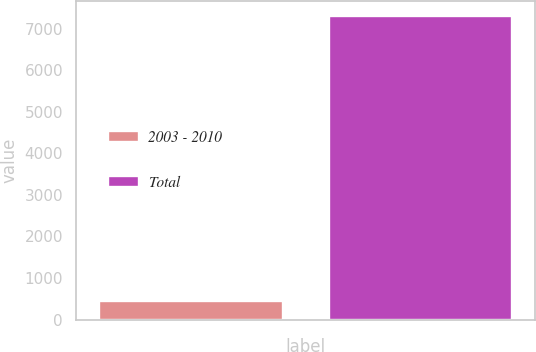<chart> <loc_0><loc_0><loc_500><loc_500><bar_chart><fcel>2003 - 2010<fcel>Total<nl><fcel>444<fcel>7294<nl></chart> 